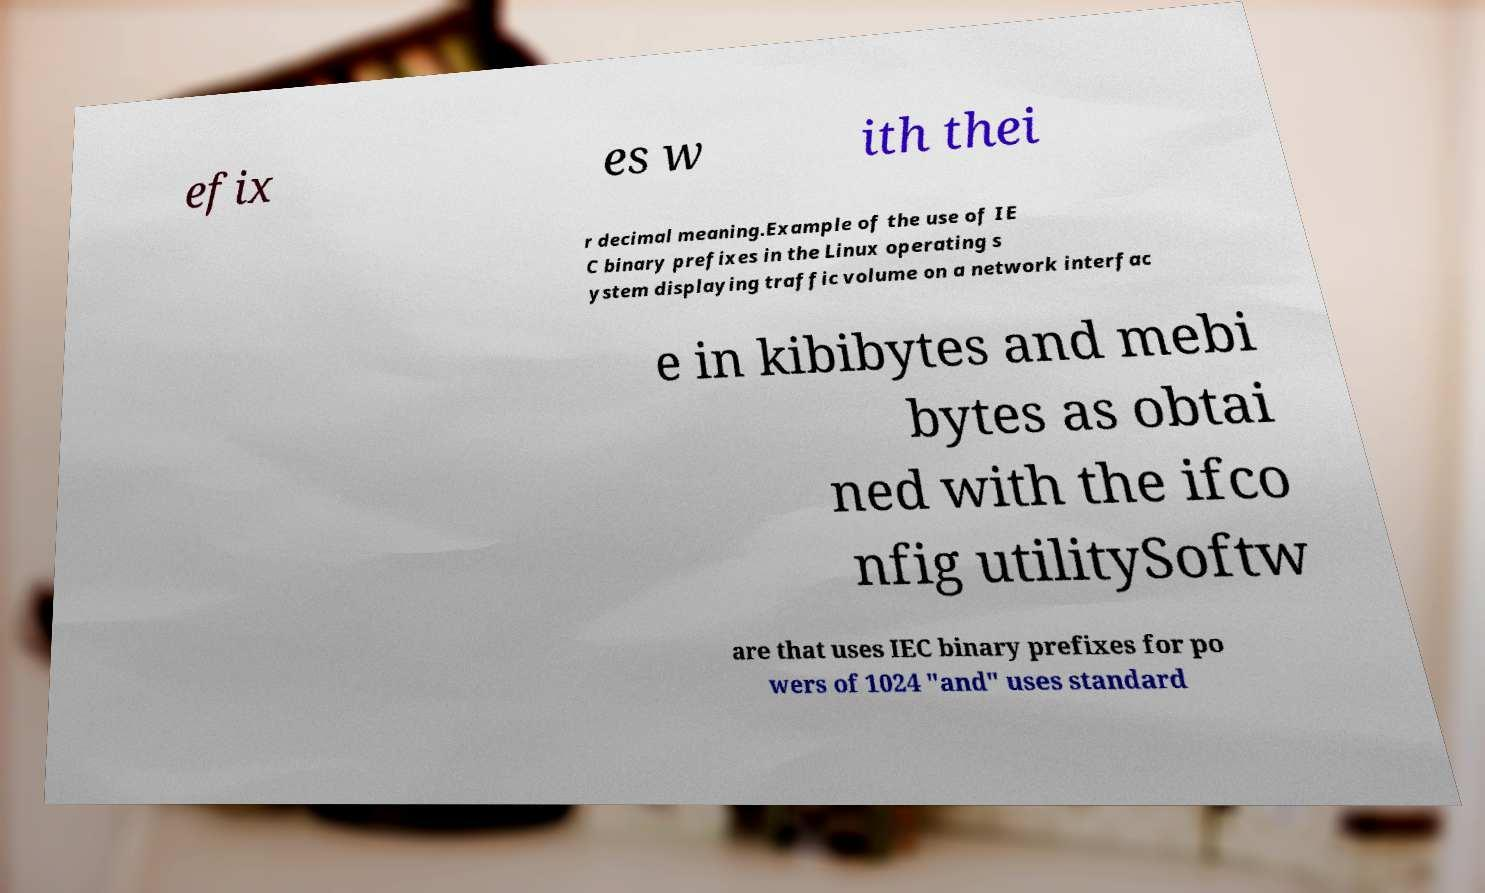Could you extract and type out the text from this image? efix es w ith thei r decimal meaning.Example of the use of IE C binary prefixes in the Linux operating s ystem displaying traffic volume on a network interfac e in kibibytes and mebi bytes as obtai ned with the ifco nfig utilitySoftw are that uses IEC binary prefixes for po wers of 1024 "and" uses standard 